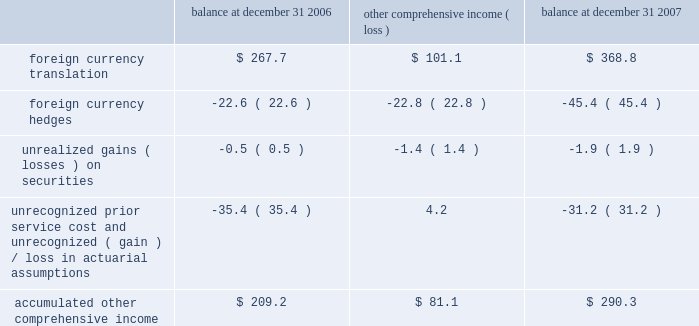Which , $ 44.9 million , or $ 38.2 million , net of taxes , is expected to be reclassified to earnings over the next twelve months .
We also enter into foreign currency forward exchange contracts with terms of one month to manage currency exposures for assets and liabilities denominated in a currency other than an entity 2019s functional currency .
As a result , any foreign currency translation gains/losses recognized in earnings under sfas no .
52 , 201cforeign currency translation 201d are generally offset with gains/losses on the foreign currency forward exchange contracts in the same reporting period .
Other comprehensive income 2013 other comprehensive income refers to revenues , expenses , gains and losses that under generally accepted accounting principles are included in comprehensive income but are excluded from net earnings as these amounts are recorded directly as an adjustment to stockholders 2019 equity .
Other comprehensive income is comprised of foreign currency translation adjustments , unrealized foreign currency hedge gains and losses , unrealized gains and losses on available-for-sale securities and amortization of prior service costs and unrecognized gains and losses in actuarial assumptions .
The components of accumulated other comprehensive income are as follows ( in millions ) : balance at december 31 , comprehensive income ( loss ) balance at december 31 .
Treasury stock 2013 we account for repurchases of common stock under the cost method and present treasury stock as a reduction of shareholders equity .
We may reissue common stock held in treasury only for limited purposes .
Accounting pronouncements 2013 in june 2006 , the fasb issued interpretation no .
48 , 201caccounting for uncertainty in income taxes , an interpretation of fas 109 , accounting for income taxes 201d ( fin 48 ) , to create a single model to address accounting for uncertainty in tax positions .
See our income tax disclosures in note 11 for more information regarding the adoption of fin 48 .
In september 2006 , the fasb issued sfas no .
158 , 201cemployers 2019 accounting for defined benefit pension and other postretirement plans 2013 an amendment of fasb statements no .
87 , 88 , 106 and 132 ( r ) . 201d this statement requires recognition of the funded status of a benefit plan in the statement of financial position .
Sfas no .
158 also requires recognition in other comprehensive income of certain gains and losses that arise during the period but are deferred under pension accounting rules , as well as modifies the timing of reporting and adds certain disclosures .
The statement provides recognition and disclosure elements to be effective as of the end of the fiscal year after december 15 , 2006 and measurement elements to be effective for fiscal years ending after december 15 , 2008 .
We adopted sfas no .
158 on december 31 , 2006 .
See our pension and other postretirement disclosures in note 10 .
In december 2004 , the fasb issued sfas no .
123 ( r ) , 201cshare-based payment 201d , which is a revision to sfas no .
123 .
Sfas 123 ( r ) requires all share-based payments to employees , including stock options , to be expensed based on their fair values .
We adopted sfas 123 ( r ) on january 1 , 2006 using the modified prospective method and did not restate prior periods .
In september 2006 , the fasb issued sfas no .
157 , 201cfair value measurements 201d , which defines fair value , establishes a framework for measuring fair value in generally accepted accounting principles and expands disclosures about fair value measurements .
This statement does not require any new fair value measurements , but provides guidance on how to measure fair value by providing a fair value hierarchy used to classify the source of the information .
Sfas no .
157 is effective for financial statements issued for fiscal years beginning after november 15 , 2007 and interim periods within those fiscal years .
In february 2008 , the fasb issued fasb staff position ( fsp ) no .
Sfas 157-2 , which delays the effective date of certain provisions of sfas no .
157 relating to non-financial assets and liabilities measured at fair value on a non-recurring basis until fiscal years beginning after november 15 , 2008 .
The adoption of sfas no .
157 is not expected to have a material impact on our consolidated financial statements or results of operations .
In february 2007 , the fasb issued sfas no .
159 , 201cthe fair value option for financial assets and financial liabilities 2013 including an amendment of fasb statement no .
115 201d ( sfas no .
159 ) .
Sfas no .
159 creates a 201cfair value option 201d under which an entity may elect to record certain financial assets or liabilities at fair value upon their initial recognition .
Subsequent changes in fair value would be recognized in earnings as those changes occur .
The election of the fair value option would be made on a contract-by-contract basis and would need to be supported by concurrent documentation or a preexisting documented policy .
Sfas no .
159 requires an entity to separately disclose the fair z i m m e r h o l d i n g s , i n c .
2 0 0 7 f o r m 1 0 - k a n n u a l r e p o r t notes to consolidated financial statements ( continued ) .
What is the change in percentage of accumulated other comprehensive income from 2006 to 2007? 
Computations: (81.1 / 209.2)
Answer: 0.38767. 